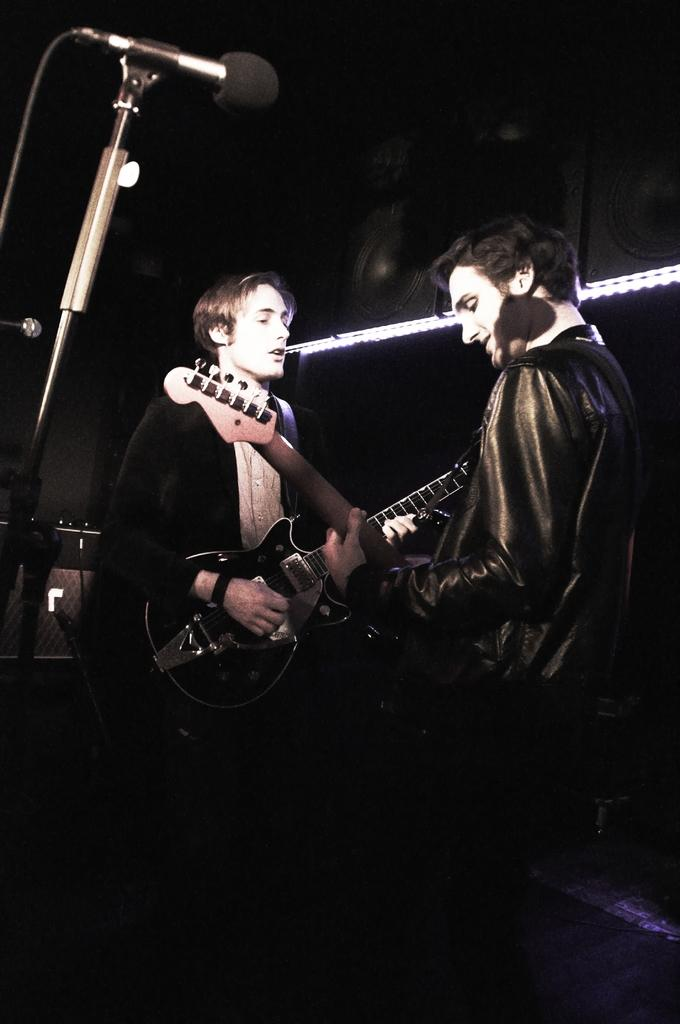How many people are in the image? There are two persons in the image. What are the two persons doing? They are playing guitar. What object is in front of them? They are in front of a microphone. What other equipment can be seen in the image? There is a speaker and a light in the image. How does the disgusting smell increase in the image? There is no mention of a disgusting smell in the image; it features two people playing guitar in front of a microphone, with a speaker and a light present. 